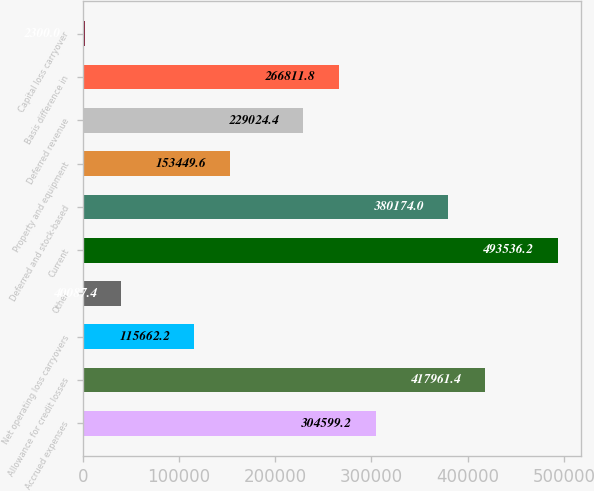Convert chart. <chart><loc_0><loc_0><loc_500><loc_500><bar_chart><fcel>Accrued expenses<fcel>Allowance for credit losses<fcel>Net operating loss carryovers<fcel>Other<fcel>Current<fcel>Deferred and stock-based<fcel>Property and equipment<fcel>Deferred revenue<fcel>Basis difference in<fcel>Capital loss carryover<nl><fcel>304599<fcel>417961<fcel>115662<fcel>40087.4<fcel>493536<fcel>380174<fcel>153450<fcel>229024<fcel>266812<fcel>2300<nl></chart> 